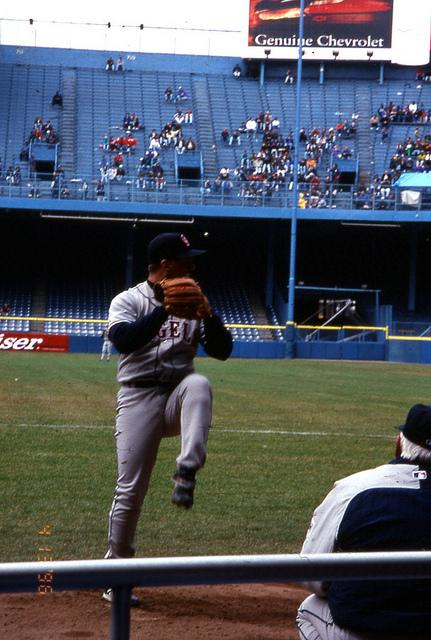What is the nickname of the motor vehicle company advertised? Please explain your reasoning. chevy. An ad for chevrolet can be seen at a baseball stadium. 